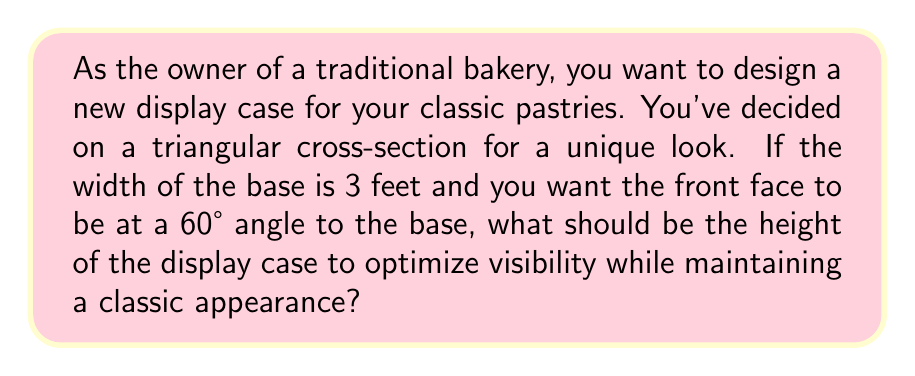Could you help me with this problem? Let's approach this step-by-step using trigonometry:

1) We can visualize the cross-section of the display case as a right-angled triangle.

2) We know:
   - The width of the base is 3 feet
   - The angle between the front face and the base is 60°

3) We need to find the height, which is the opposite side to the 60° angle.

4) In a right-angled triangle, we can use the tangent function to find the ratio of the opposite side to the adjacent side:

   $$ \tan \theta = \frac{\text{opposite}}{\text{adjacent}} $$

5) In this case:
   $$ \tan 60° = \frac{\text{height}}{3} $$

6) We know that $\tan 60° = \sqrt{3}$, so:

   $$ \sqrt{3} = \frac{\text{height}}{3} $$

7) To solve for height, multiply both sides by 3:

   $$ 3\sqrt{3} = \text{height} $$

8) This can be simplified to:

   $$ \text{height} = 3\sqrt{3} \approx 5.196 \text{ feet} $$

[asy]
import geometry;

size(200);
pair A = (0,0), B = (3,0), C = (0,3*sqrt(3));
draw(A--B--C--A);
draw(B--(3,0.5), arrow=Arrow(TeXHead));
draw(C--(0.5,3*sqrt(3)), arrow=Arrow(TeXHead));
label("3 ft", (1.5,0), S);
label("$3\sqrt{3}$ ft", (0,1.5*sqrt(3)), W);
label("60°", (0.3,0.3), NE);
[/asy]
Answer: The optimal height of the display case should be $3\sqrt{3}$ feet, or approximately 5.196 feet. 